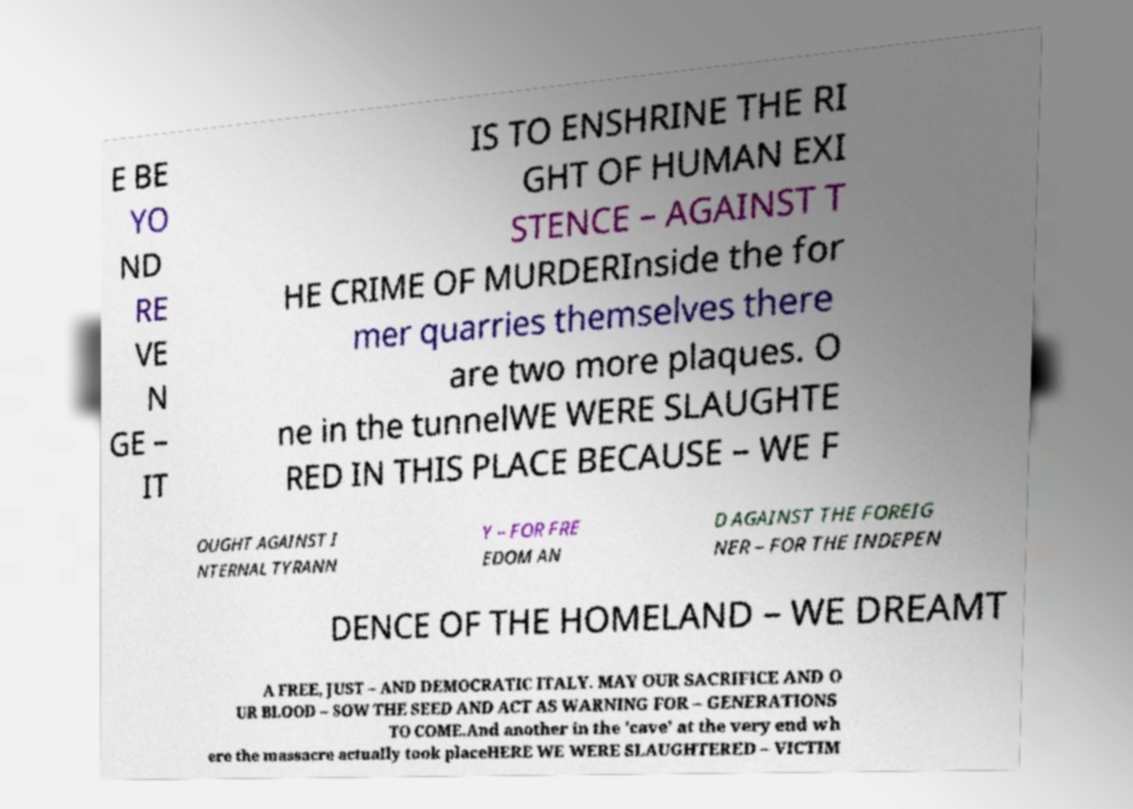Could you extract and type out the text from this image? E BE YO ND RE VE N GE – IT IS TO ENSHRINE THE RI GHT OF HUMAN EXI STENCE – AGAINST T HE CRIME OF MURDERInside the for mer quarries themselves there are two more plaques. O ne in the tunnelWE WERE SLAUGHTE RED IN THIS PLACE BECAUSE – WE F OUGHT AGAINST I NTERNAL TYRANN Y – FOR FRE EDOM AN D AGAINST THE FOREIG NER – FOR THE INDEPEN DENCE OF THE HOMELAND – WE DREAMT A FREE, JUST – AND DEMOCRATIC ITALY. MAY OUR SACRIFICE AND O UR BLOOD – SOW THE SEED AND ACT AS WARNING FOR – GENERATIONS TO COME.And another in the 'cave' at the very end wh ere the massacre actually took placeHERE WE WERE SLAUGHTERED – VICTIM 